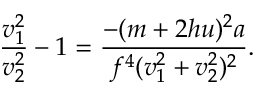Convert formula to latex. <formula><loc_0><loc_0><loc_500><loc_500>{ \frac { v _ { 1 } ^ { 2 } } { v _ { 2 } ^ { 2 } } } - 1 = { \frac { - ( m + 2 h u ) ^ { 2 } a } { f ^ { 4 } ( v _ { 1 } ^ { 2 } + v _ { 2 } ^ { 2 } ) ^ { 2 } } } .</formula> 